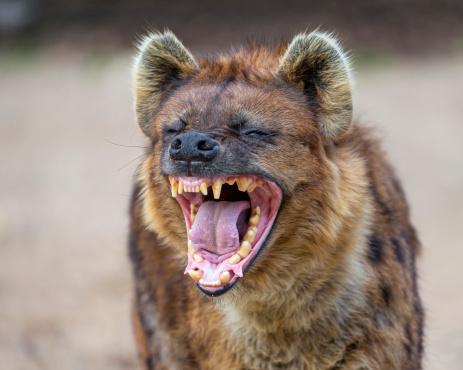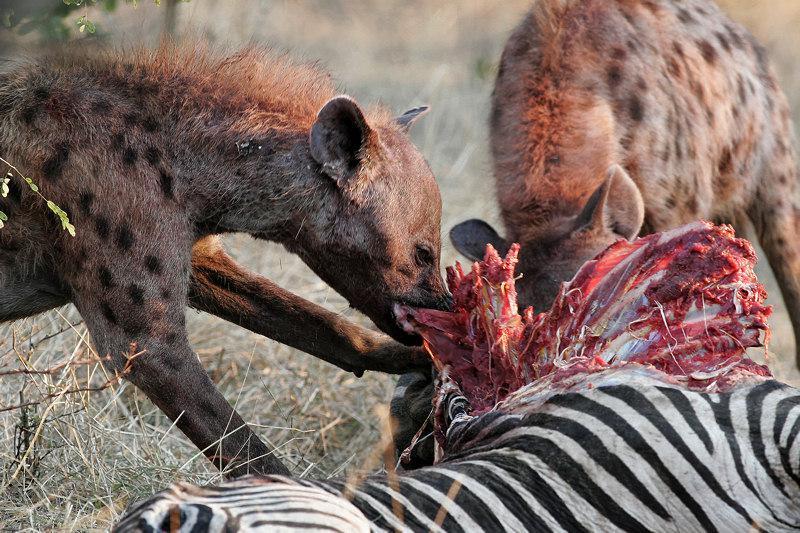The first image is the image on the left, the second image is the image on the right. For the images shown, is this caption "The right image shows at least one hyena grasping at a zebra carcass with its black and white striped hide still partly intact." true? Answer yes or no. Yes. 